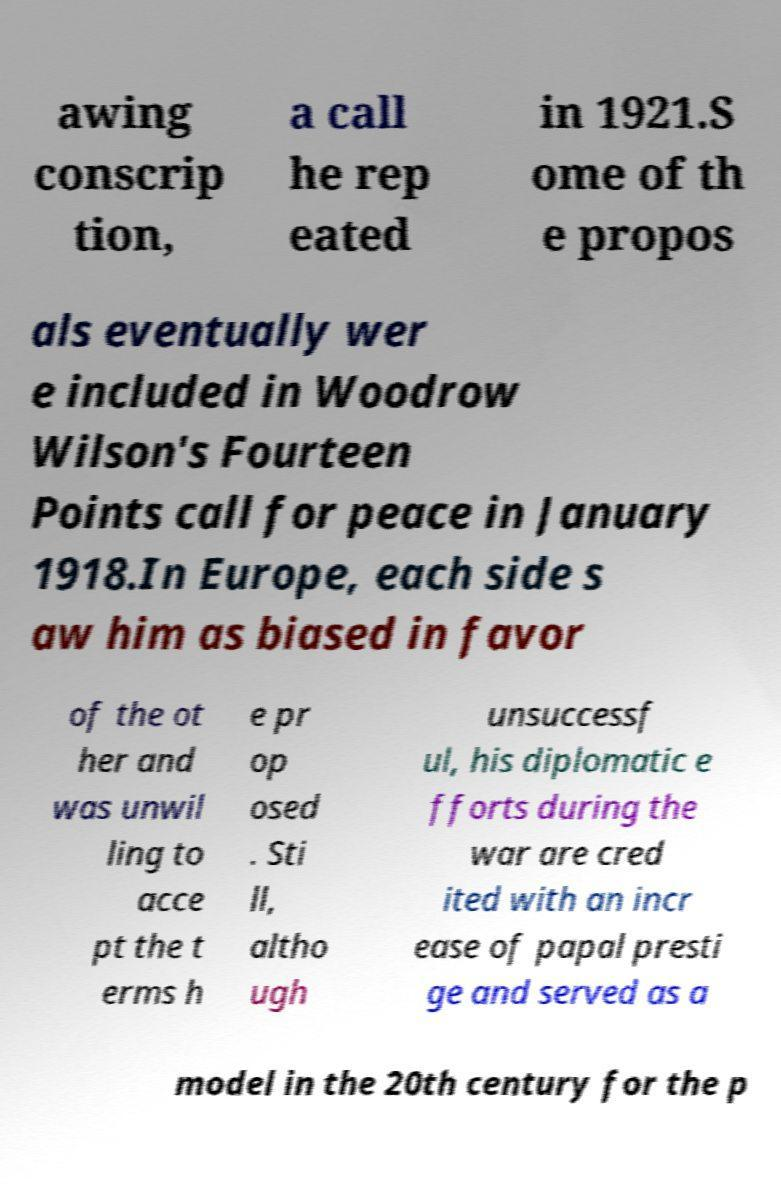Please identify and transcribe the text found in this image. awing conscrip tion, a call he rep eated in 1921.S ome of th e propos als eventually wer e included in Woodrow Wilson's Fourteen Points call for peace in January 1918.In Europe, each side s aw him as biased in favor of the ot her and was unwil ling to acce pt the t erms h e pr op osed . Sti ll, altho ugh unsuccessf ul, his diplomatic e fforts during the war are cred ited with an incr ease of papal presti ge and served as a model in the 20th century for the p 